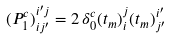Convert formula to latex. <formula><loc_0><loc_0><loc_500><loc_500>( P ^ { c } _ { 1 } ) ^ { i ^ { \prime } j } _ { i j ^ { \prime } } = 2 \, \delta ^ { c } _ { 0 } ( t _ { m } ) ^ { j } _ { i } ( t _ { m } ) ^ { i ^ { \prime } } _ { j ^ { \prime } }</formula> 